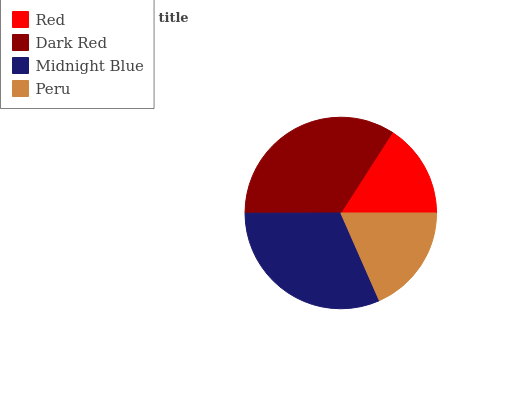Is Red the minimum?
Answer yes or no. Yes. Is Dark Red the maximum?
Answer yes or no. Yes. Is Midnight Blue the minimum?
Answer yes or no. No. Is Midnight Blue the maximum?
Answer yes or no. No. Is Dark Red greater than Midnight Blue?
Answer yes or no. Yes. Is Midnight Blue less than Dark Red?
Answer yes or no. Yes. Is Midnight Blue greater than Dark Red?
Answer yes or no. No. Is Dark Red less than Midnight Blue?
Answer yes or no. No. Is Midnight Blue the high median?
Answer yes or no. Yes. Is Peru the low median?
Answer yes or no. Yes. Is Peru the high median?
Answer yes or no. No. Is Dark Red the low median?
Answer yes or no. No. 